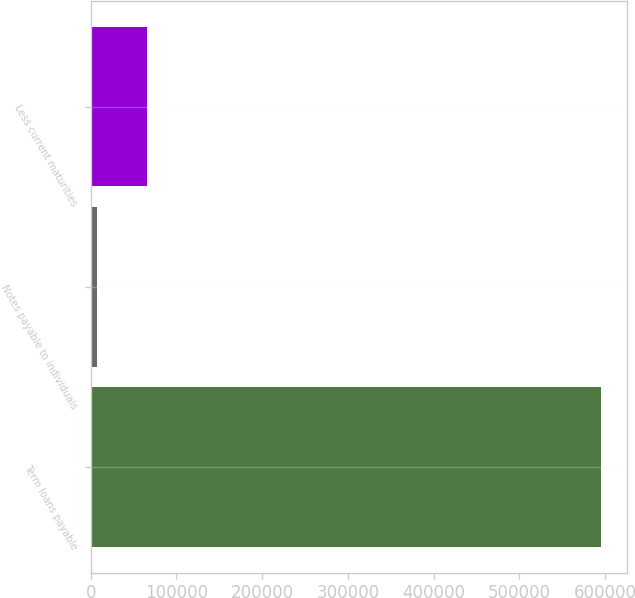Convert chart to OTSL. <chart><loc_0><loc_0><loc_500><loc_500><bar_chart><fcel>Term loans payable<fcel>Notes payable to individuals<fcel>Less current maturities<nl><fcel>595716<fcel>7329<fcel>66167.7<nl></chart> 